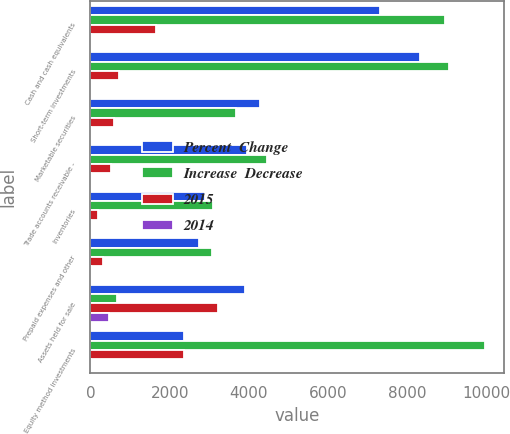<chart> <loc_0><loc_0><loc_500><loc_500><stacked_bar_chart><ecel><fcel>Cash and cash equivalents<fcel>Short-term investments<fcel>Marketable securities<fcel>Trade accounts receivable -<fcel>Inventories<fcel>Prepaid expenses and other<fcel>Assets held for sale<fcel>Equity method investments<nl><fcel>Percent  Change<fcel>7309<fcel>8322<fcel>4269<fcel>3941<fcel>2902<fcel>2752<fcel>3900<fcel>2371<nl><fcel>Increase  Decrease<fcel>8958<fcel>9052<fcel>3665<fcel>4466<fcel>3100<fcel>3066<fcel>679<fcel>9947<nl><fcel>2015<fcel>1649<fcel>730<fcel>604<fcel>525<fcel>198<fcel>314<fcel>3221<fcel>2371<nl><fcel>2014<fcel>18<fcel>8<fcel>16<fcel>12<fcel>6<fcel>10<fcel>474<fcel>24<nl></chart> 